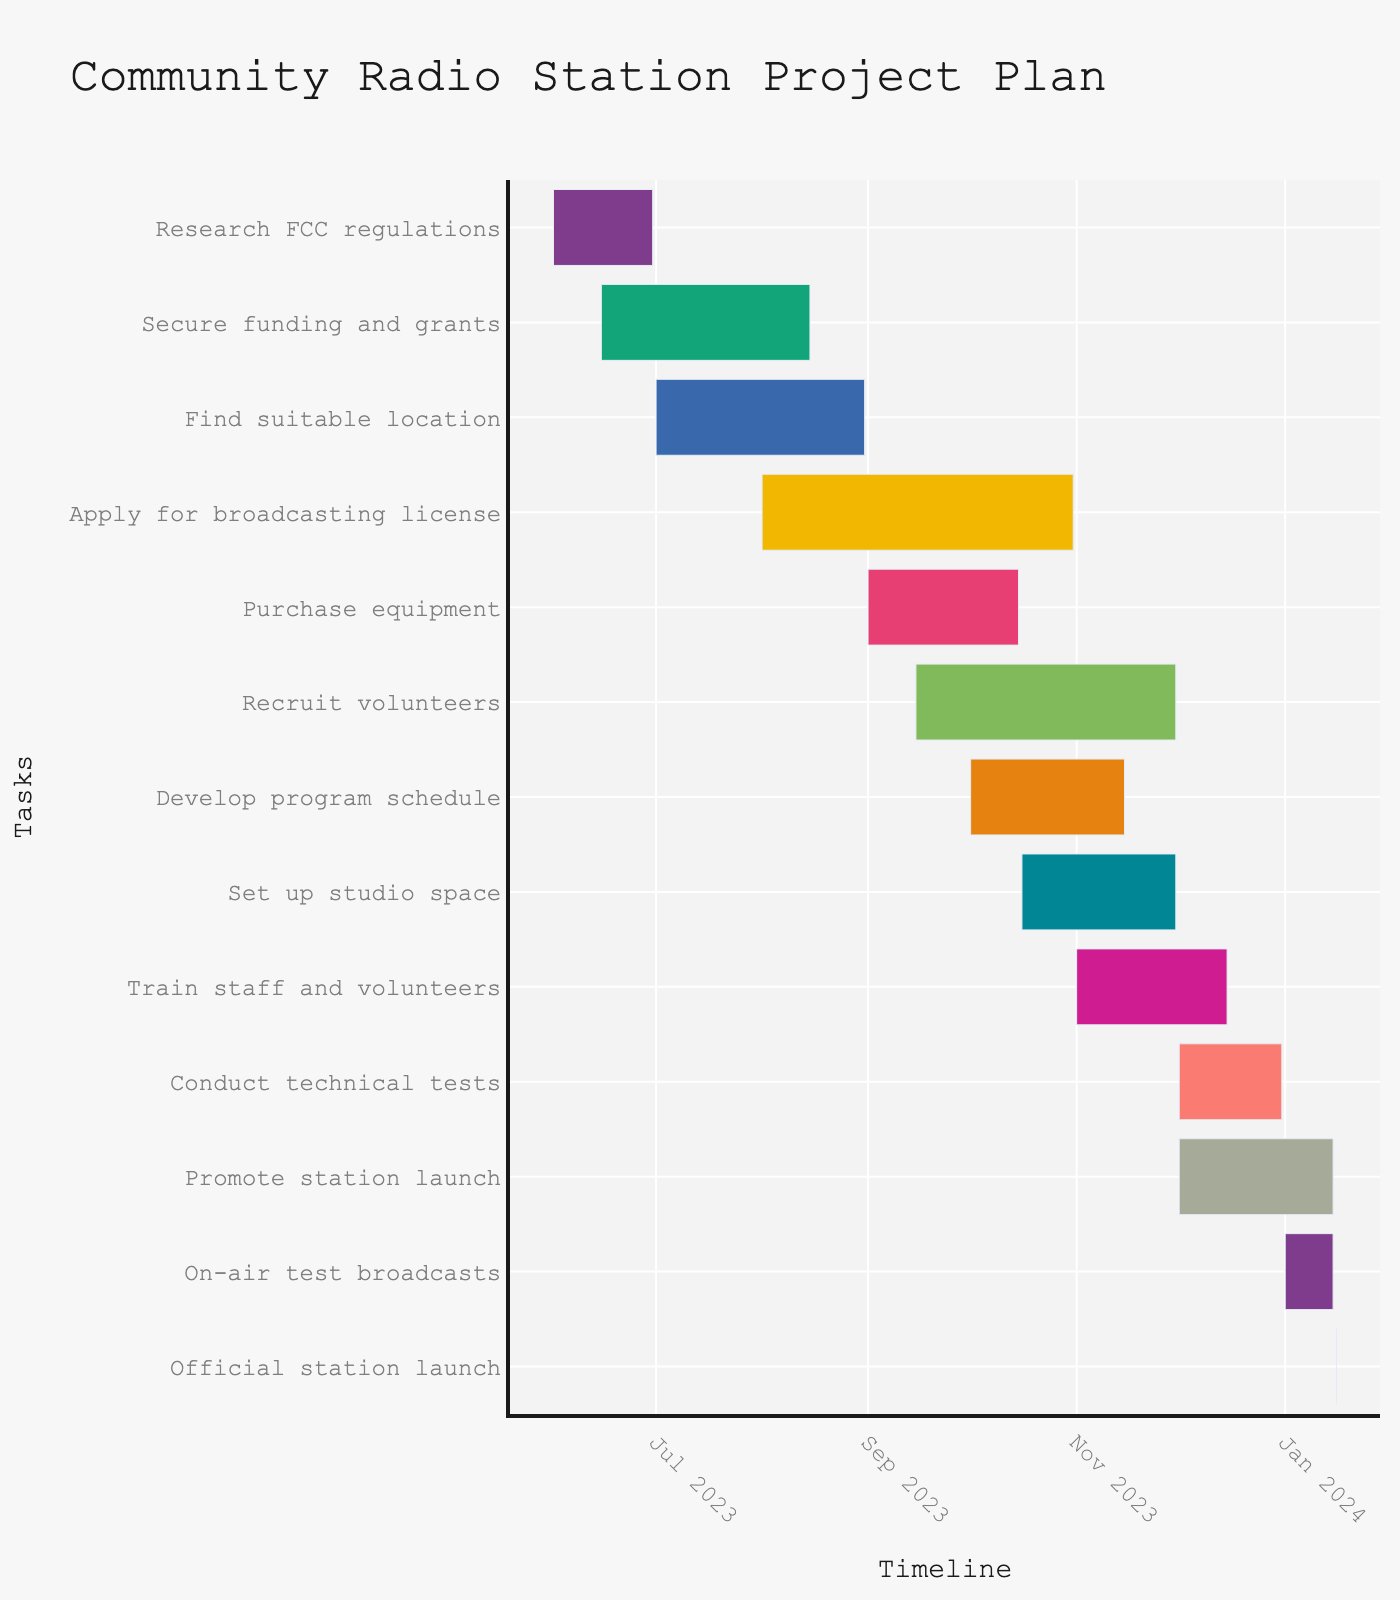What is the title of the Gantt chart? The title is prominently displayed at the top of the Gantt chart.
Answer: Community Radio Station Project Plan When does the task "Secure funding and grants" start and end? By locating the "Secure funding and grants" task on the y-axis and checking the corresponding x-axis values, we see it starts on June 15, 2023, and ends on August 15, 2023.
Answer: June 15, 2023, to August 15, 2023 How long does the "Apply for broadcasting license" task take? Find the "Apply for broadcasting license" task and note its start and end dates, which are August 1, 2023, and October 31, 2023. The duration is also 92 days according to the custom hover data.
Answer: 92 days Which task has the shortest duration? By examining the lengths of the tasks and checking their durations, "Official station launch" has the shortest duration of just 1 day.
Answer: Official station launch What is the combined duration of "Recruit volunteers" and "Develop program schedule"? "Recruit volunteers" lasts for 77 days and "Develop program schedule" lasts for 46 days. Summing these gives 77 + 46 = 123 days.
Answer: 123 days Which tasks overlap with the "Purchase equipment" task? "Purchase equipment" runs from September 1, 2023, to October 15, 2023. Tasks overlapping in this period are "Apply for broadcasting license," "Recruit volunteers," and "Find suitable location."
Answer: "Apply for broadcasting license," "Recruit volunteers," and "Find suitable location" How many tasks start in October 2023? By checking the start dates of each task, the tasks starting in October 2023 are "Develop program schedule" and "Set up studio space." Therefore, there are 2 tasks.
Answer: 2 Which task has the longest duration? By comparing the durations of all tasks, "Apply for broadcasting license" has the longest at 92 days.
Answer: Apply for broadcasting license When is the official station launch scheduled? The "Official station launch" task is marked on the chart, and it is scheduled for January 16, 2024.
Answer: January 16, 2024 What is the total number of days for all tasks to complete from the start of the first task to the end of the last task? The first task starts on June 1, 2023, and the last activity ends on January 15, 2024. Calculating the difference between these dates: January 15, 2024 - June 1, 2023 = 229 days.
Answer: 229 days 